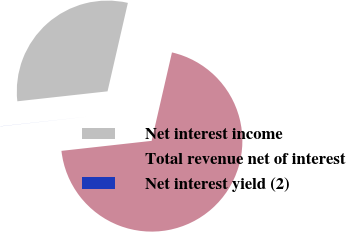Convert chart to OTSL. <chart><loc_0><loc_0><loc_500><loc_500><pie_chart><fcel>Net interest income<fcel>Total revenue net of interest<fcel>Net interest yield (2)<nl><fcel>30.35%<fcel>69.65%<fcel>0.01%<nl></chart> 